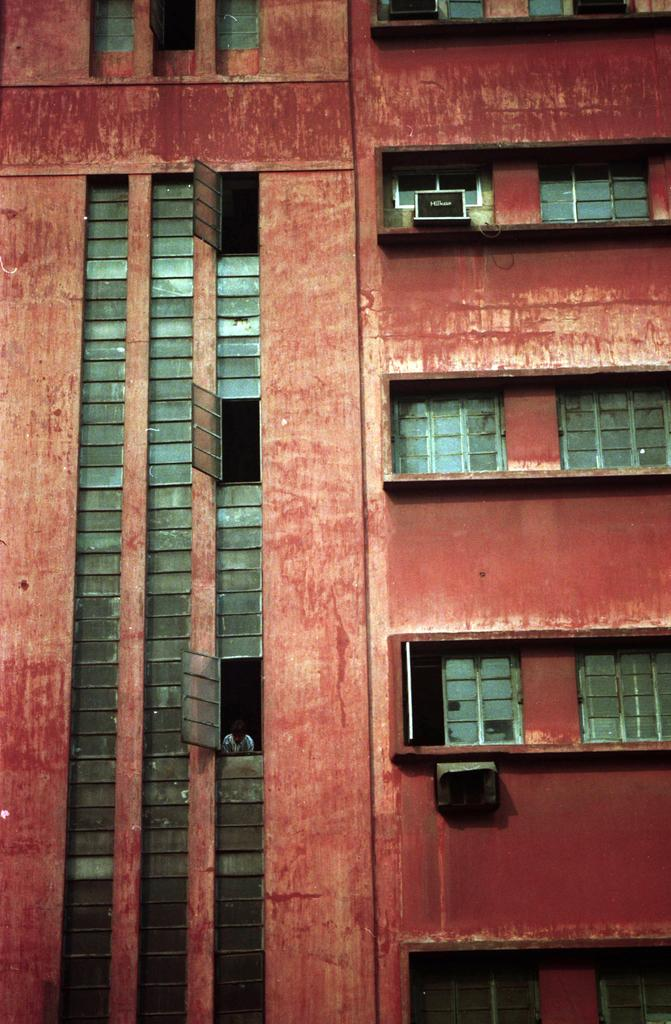What is the color of the building in the image? The building in the image is red. What type of windows does the building have? The building has glass windows. How many cats are sitting on the roof of the building in the image? There is no information about cats on the roof of the building in the image. What type of advice is being given by the building in the image? The building is not capable of giving advice, as it is an inanimate object. What kind of horn is attached to the building in the image? There is no horn attached to the building in the image. 